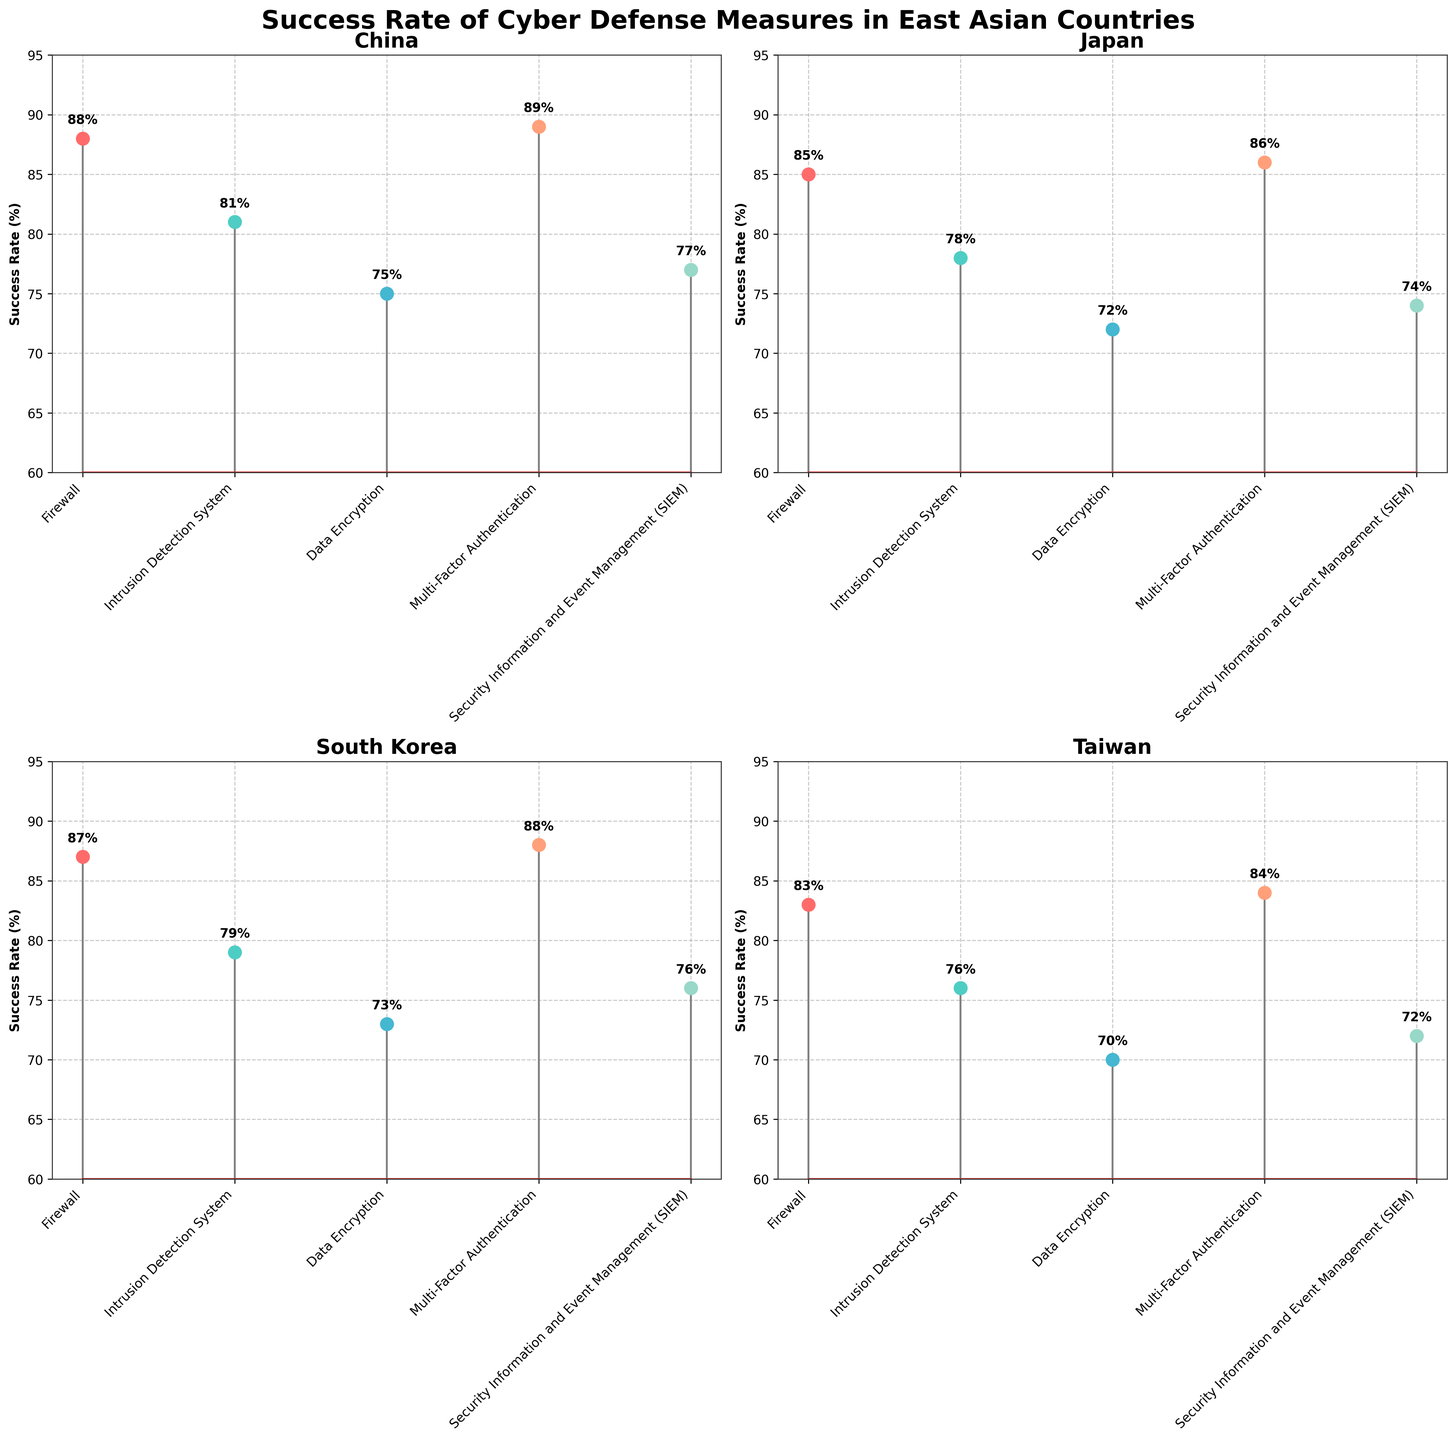What is the title of the figure? The title is usually located at the top of the figure and provides a general idea of what the figure is about. In this case, the title is "Success Rate of Cyber Defense Measures in East Asian Countries."
Answer: Success Rate of Cyber Defense Measures in East Asian Countries What cyber defense measure has the highest success rate in China? In the subplot for China, the highest data point represents the highest success rate. The measure with the highest success rate is Multi-Factor Authentication at 89%.
Answer: Multi-Factor Authentication Which country has the highest success rate for Firewalls? By looking at the success rates listed for Firewalls in each subplot, the highest success rate is in China with 88%.
Answer: China How does the success rate of Data Encryption compare between Japan and South Korea? Check the success rate of Data Encryption in the subplots for Japan and South Korea. Japan's success rate is 72%, while South Korea's is 73%.
Answer: South Korea What is the average success rate of Intrusion Detection System across all countries? Add the success rates of Intrusion Detection System for each country (81, 78, 79, 76) and then divide by the number of countries (4). (81 + 78 + 79 + 76) / 4 = 78.5%
Answer: 78.5% Which country has the lowest success rate for Security Information and Event Management (SIEM)? Review the success rates for SIEM in each subplot. Taiwan has the lowest success rate with 72%.
Answer: Taiwan What is the difference in success rate for Multi-Factor Authentication between South Korea and Taiwan? The success rate for Multi-Factor Authentication in South Korea is 88%, and in Taiwan, it is 84%. The difference is 88% - 84% = 4%.
Answer: 4% Is there any cyber defense measure where Japan and Taiwan have the same success rate? Compare each cyber defense measure's success rate for Japan and Taiwan. Both countries have the same success rate for Data Encryption at 72%.
Answer: Data Encryption What cyber defense measure has the most consistent success rates across all countries? Calculate the range (max success rate - min success rate) for each measure. The measure with the smallest range is the most consistent. Multi-Factor Authentication ranges from 84% to 89%, which is the smallest range (5%).
Answer: Multi-Factor Authentication Which country's subplot shows the highest overall consistency in success rates among various measures? Compare the ranges of success rates in each country's subplot. A smaller range indicates higher consistency. Taiwan's range is (84% - 70%) = 14%, which is the smallest gap.
Answer: Taiwan 